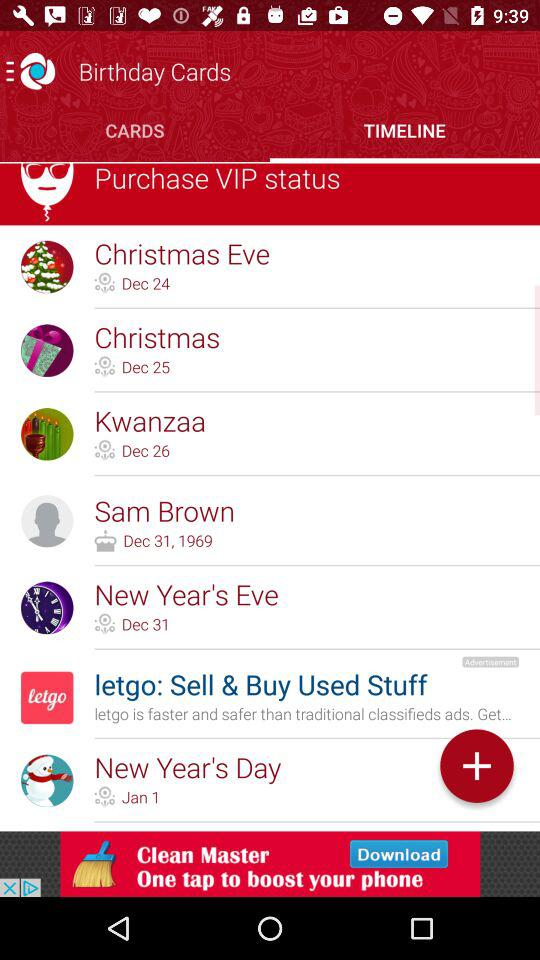What is the profile name?
When the provided information is insufficient, respond with <no answer>. <no answer> 